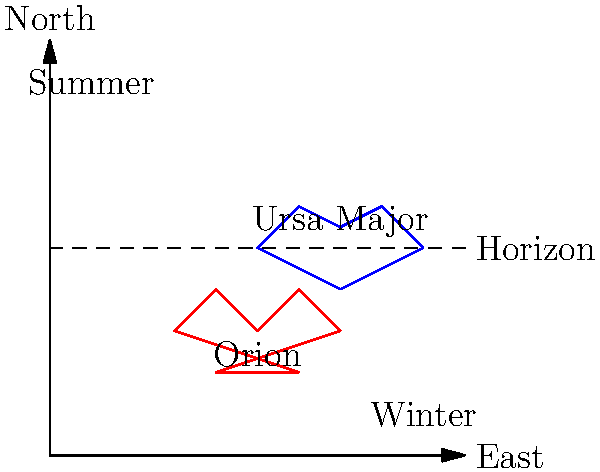As an IT student with an interest in law enforcement, you're developing a software application to track celestial patterns. Which constellation shown in the diagram is more visible during summer nights in the Northern Hemisphere, and why? To answer this question, let's analyze the diagram step-by-step:

1. The diagram shows two constellations: Ursa Major (blue) and Orion (red).

2. The horizontal dashed line represents the horizon, with the area above it being visible in the night sky.

3. The vertical axis represents the North direction, while the horizontal axis represents the East direction.

4. Ursa Major is positioned higher in the northern sky, mostly above the horizon line.

5. Orion is positioned lower, closer to the southern sky, and partially below the horizon line.

6. The diagram indicates "Summer" in the upper-left quadrant and "Winter" in the lower-right quadrant.

7. In the Northern Hemisphere, during summer:
   a. The North Celestial Pole is tilted towards the Sun.
   b. Northern constellations appear higher in the sky.
   c. Southern constellations may dip below the horizon or be less visible.

8. Conversely, during winter in the Northern Hemisphere:
   a. The North Celestial Pole is tilted away from the Sun.
   b. Southern constellations appear higher in the sky.

9. Given this information, Ursa Major, being a northern constellation, would be more visible during summer nights in the Northern Hemisphere.

10. Orion, being a southern constellation, would be more visible during winter nights in the Northern Hemisphere.

Therefore, the constellation more visible during summer nights in the Northern Hemisphere is Ursa Major.
Answer: Ursa Major 